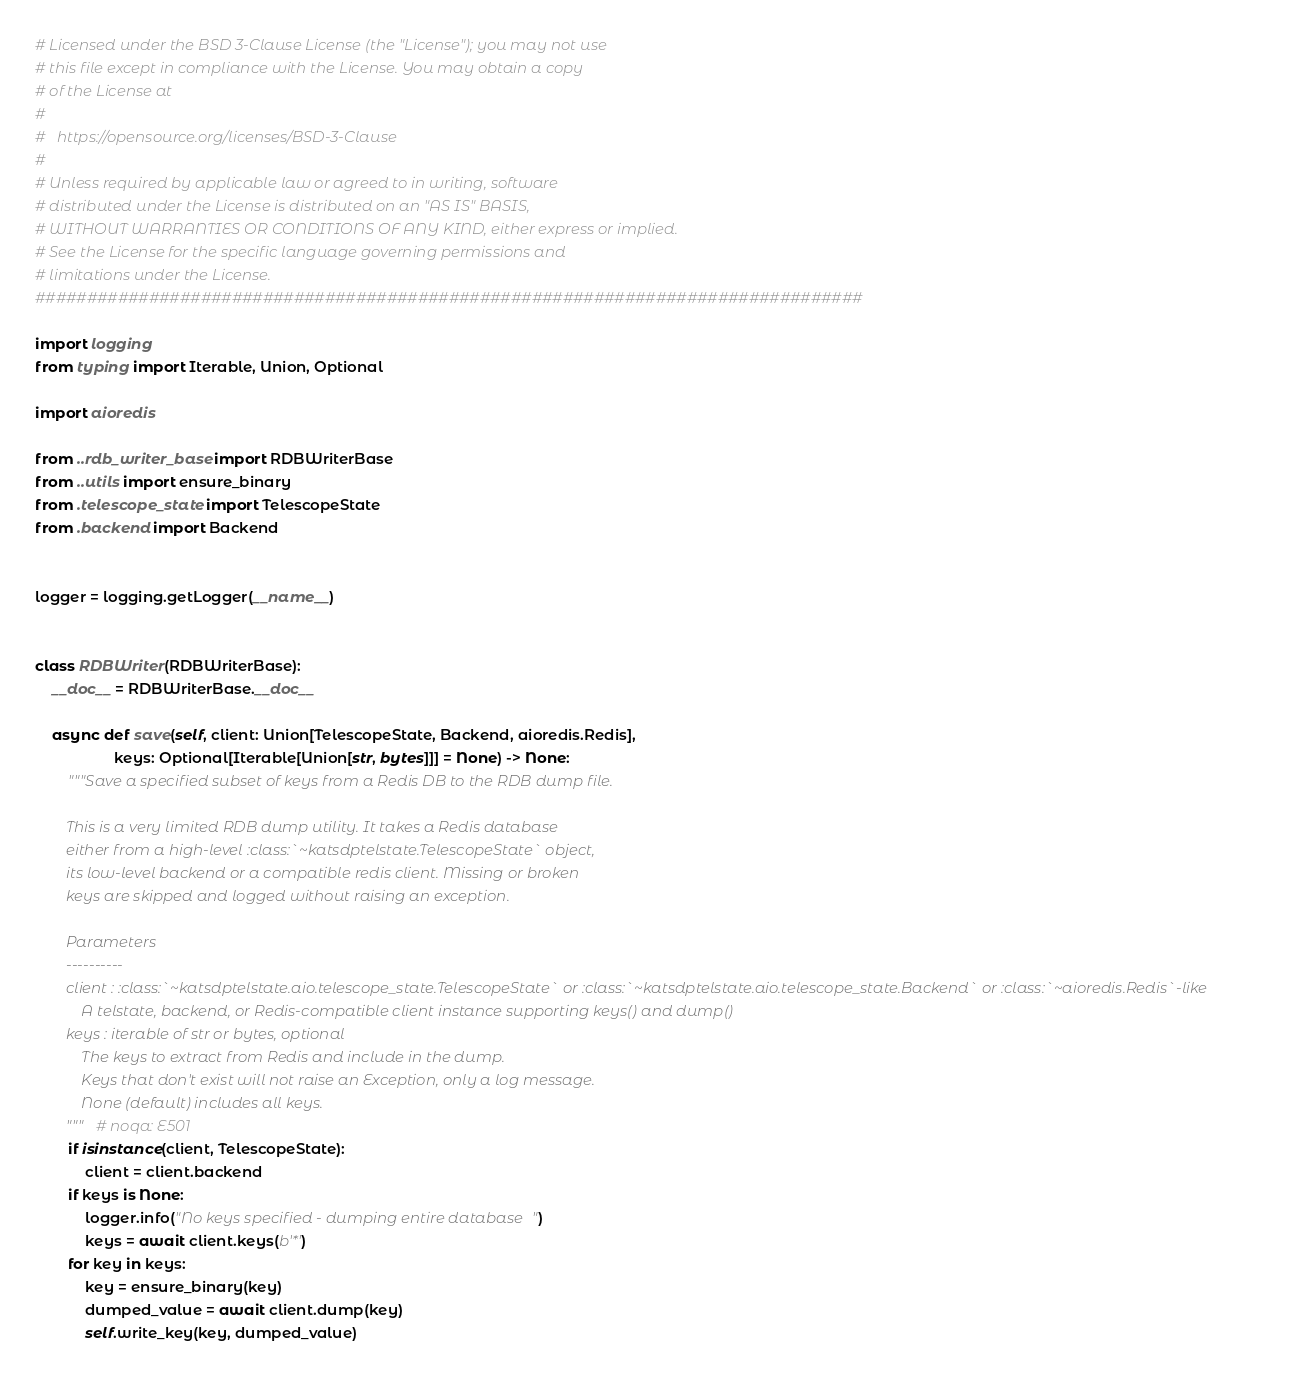<code> <loc_0><loc_0><loc_500><loc_500><_Python_># Licensed under the BSD 3-Clause License (the "License"); you may not use
# this file except in compliance with the License. You may obtain a copy
# of the License at
#
#   https://opensource.org/licenses/BSD-3-Clause
#
# Unless required by applicable law or agreed to in writing, software
# distributed under the License is distributed on an "AS IS" BASIS,
# WITHOUT WARRANTIES OR CONDITIONS OF ANY KIND, either express or implied.
# See the License for the specific language governing permissions and
# limitations under the License.
################################################################################

import logging
from typing import Iterable, Union, Optional

import aioredis

from ..rdb_writer_base import RDBWriterBase
from ..utils import ensure_binary
from .telescope_state import TelescopeState
from .backend import Backend


logger = logging.getLogger(__name__)


class RDBWriter(RDBWriterBase):
    __doc__ = RDBWriterBase.__doc__

    async def save(self, client: Union[TelescopeState, Backend, aioredis.Redis],
                   keys: Optional[Iterable[Union[str, bytes]]] = None) -> None:
        """Save a specified subset of keys from a Redis DB to the RDB dump file.

        This is a very limited RDB dump utility. It takes a Redis database
        either from a high-level :class:`~katsdptelstate.TelescopeState` object,
        its low-level backend or a compatible redis client. Missing or broken
        keys are skipped and logged without raising an exception.

        Parameters
        ----------
        client : :class:`~katsdptelstate.aio.telescope_state.TelescopeState` or :class:`~katsdptelstate.aio.telescope_state.Backend` or :class:`~aioredis.Redis`-like
            A telstate, backend, or Redis-compatible client instance supporting keys() and dump()
        keys : iterable of str or bytes, optional
            The keys to extract from Redis and include in the dump.
            Keys that don't exist will not raise an Exception, only a log message.
            None (default) includes all keys.
        """  # noqa: E501
        if isinstance(client, TelescopeState):
            client = client.backend
        if keys is None:
            logger.info("No keys specified - dumping entire database")
            keys = await client.keys(b'*')
        for key in keys:
            key = ensure_binary(key)
            dumped_value = await client.dump(key)
            self.write_key(key, dumped_value)
</code> 